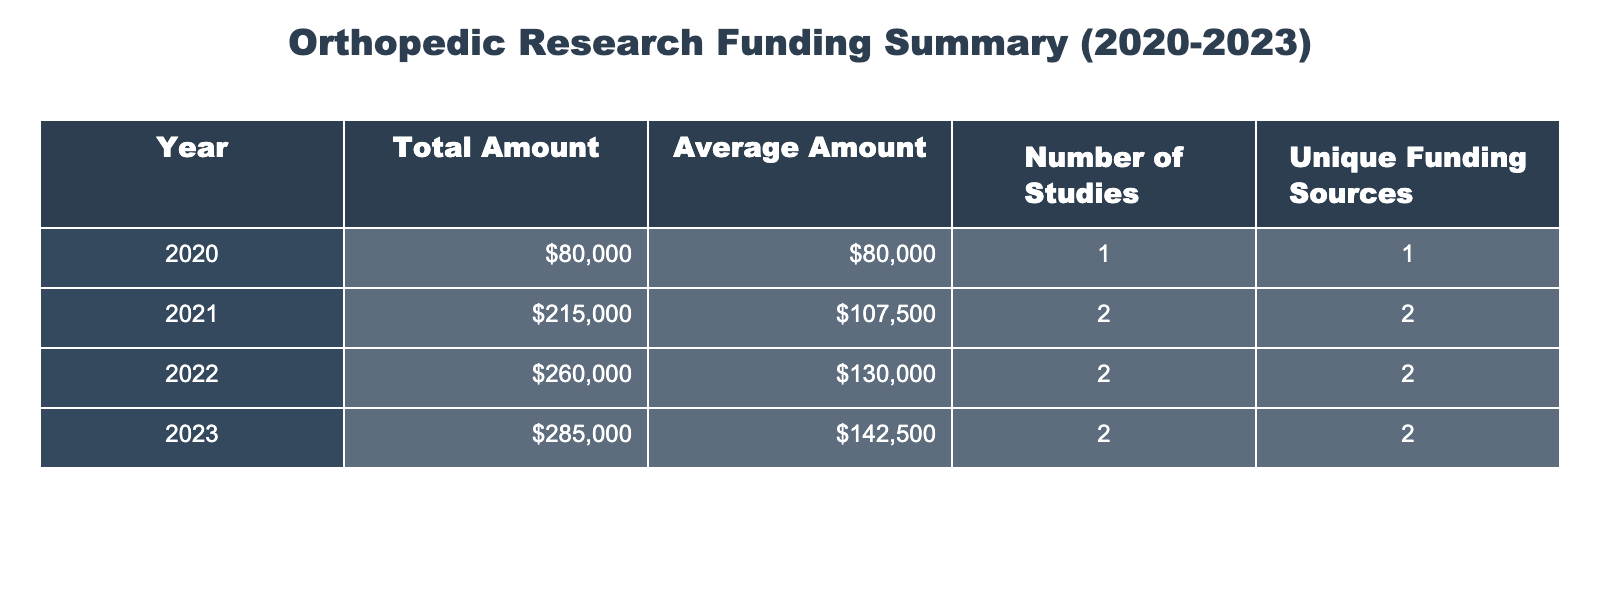What was the total funding amount for orthopedic research in 2022? In the year 2022, the table indicates two funding entries: $200,000 from the National Institutes of Health and $60,000 from the American Academy of Orthopaedic Surgeons. To find the total, we sum these amounts: 200,000 + 60,000 = $260,000.
Answer: $260,000 What is the average funding amount across all years for orthopedic studies? The table provides the total amounts for each year: $80,000 (2020), $215,000 (2021), $260,000 (2022), and $285,000 (2023). Adding them gives 80,000 + 215,000 + 260,000 + 285,000 = $840,000. There are 4 years, so to find the average: 840,000 / 4 = $210,000.
Answer: $210,000 Which funding source had the highest amount in 2023? The table shows two funding sources for 2023: the Department of Defense with $110,000 and the National Institutes of Health with $175,000. Comparing these amounts, the highest is $175,000 from NIH.
Answer: National Institutes of Health Was there any funding from the Orthopaedic Research and Education Foundation (OREF) in 2023? The table lists funding sources for each year from 2020 to 2023. The entry for 2023 shows funding from the Department of Defense and the National Institutes of Health, but OREF does not appear in this year. Thus, the answer is no.
Answer: No How many unique funding sources were there in 2021? For 2021, the table lists two funding sources: the Orthopaedic Research and Education Foundation and the National Science Foundation. Since both are distinct and there are no duplicates, the total count of unique sources is 2.
Answer: 2 What was the total funding for NIH across all years? The table includes two entries for the National Institutes of Health: $200,000 in 2022 and $175,000 in 2023. To find the total NIH funding, we add those amounts: 200,000 + 175,000 = $375,000.
Answer: $375,000 What is the difference in the total funding amount between 2020 and 2023? For 2020, the funding was $80,000, and for 2023, it was $285,000. To find the difference, we subtract the total for 2020 from that of 2023: 285,000 - 80,000 = $205,000.
Answer: $205,000 Which institution received funding for spinal surgery complications? In the year 2023, the table lists the National Institutes of Health as having funded a study on spinal surgery complications at the Cleveland Clinic. Therefore, the institution related to this funding is Cleveland Clinic.
Answer: Cleveland Clinic 